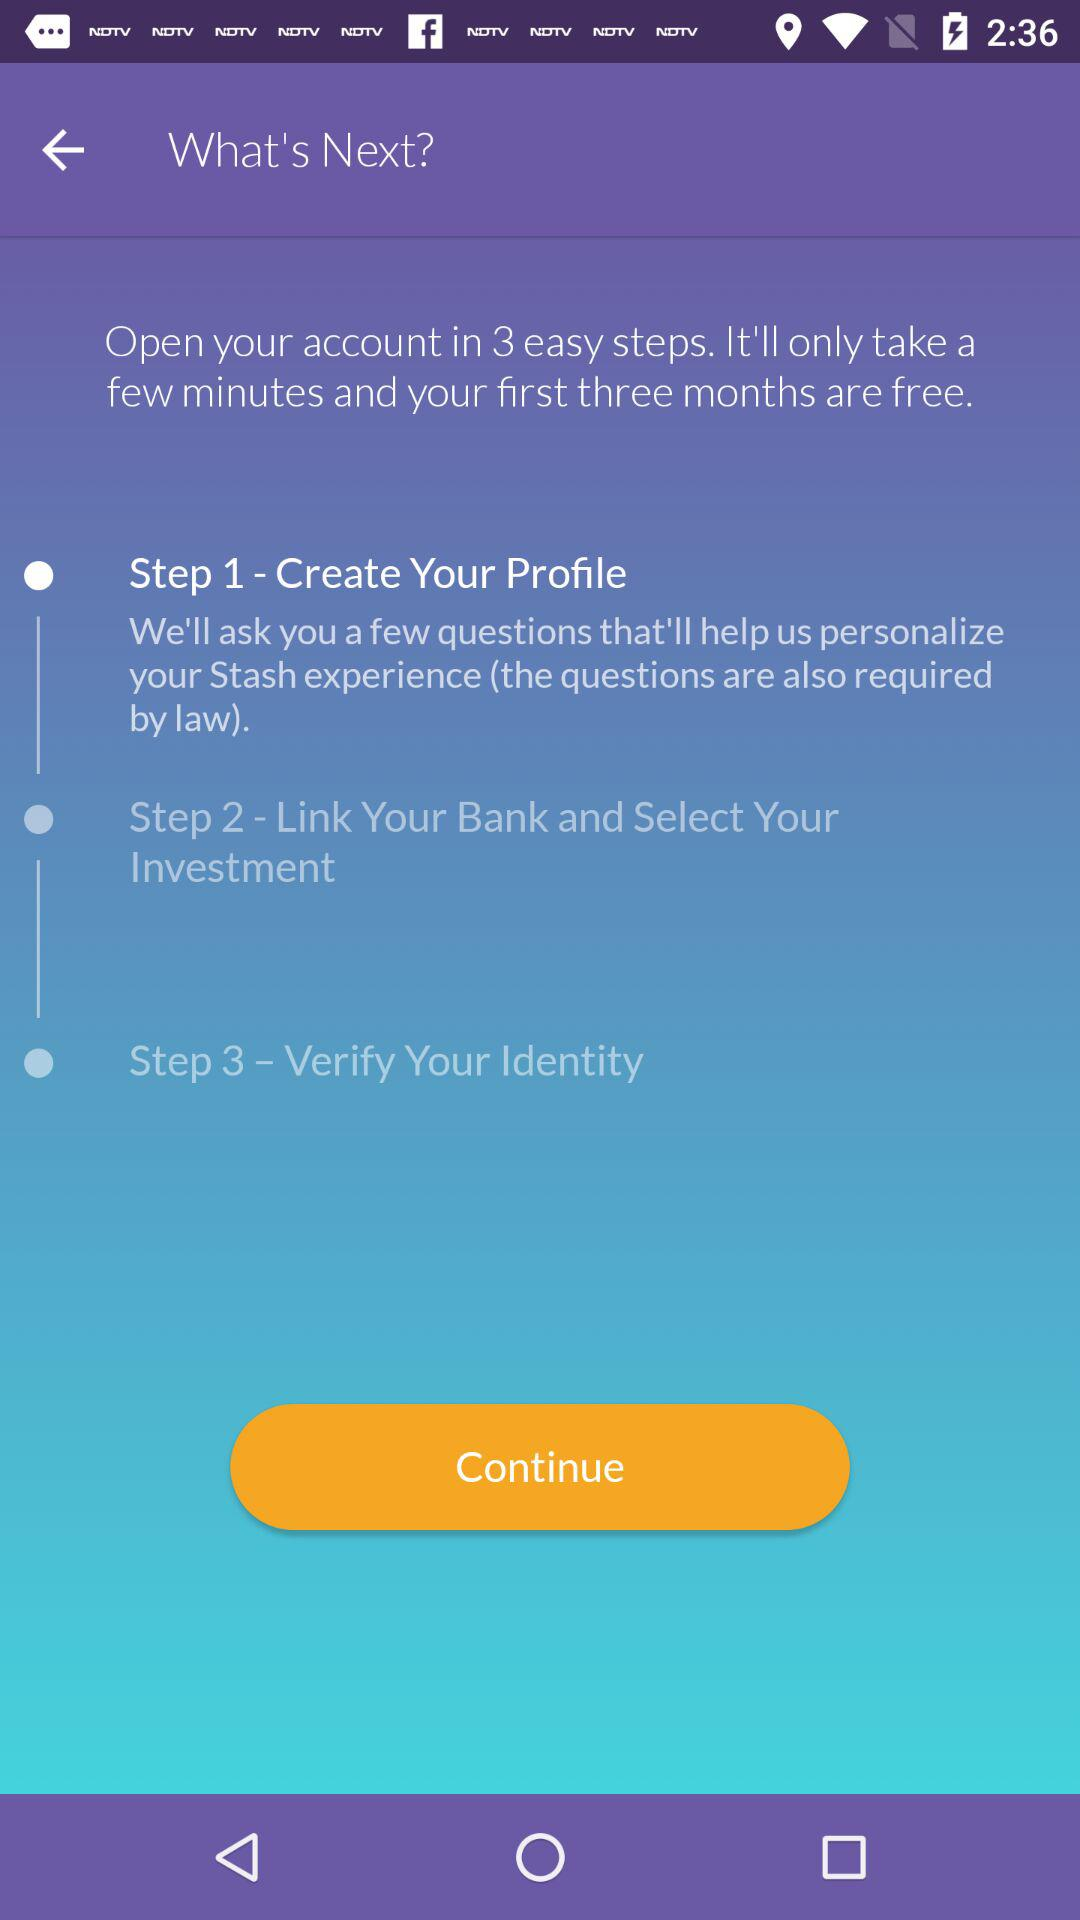How many steps are required to open the account? There are 3 steps required to open the account. 